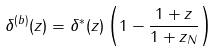Convert formula to latex. <formula><loc_0><loc_0><loc_500><loc_500>\delta ^ { ( b ) } ( z ) = \delta ^ { * } ( z ) \left ( 1 - \frac { 1 + z } { 1 + z _ { N } } \right )</formula> 